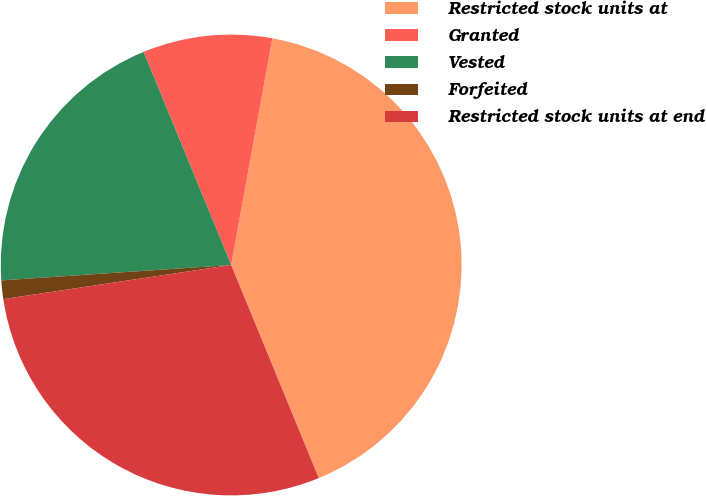Convert chart. <chart><loc_0><loc_0><loc_500><loc_500><pie_chart><fcel>Restricted stock units at<fcel>Granted<fcel>Vested<fcel>Forfeited<fcel>Restricted stock units at end<nl><fcel>40.93%<fcel>9.07%<fcel>19.86%<fcel>1.3%<fcel>28.84%<nl></chart> 